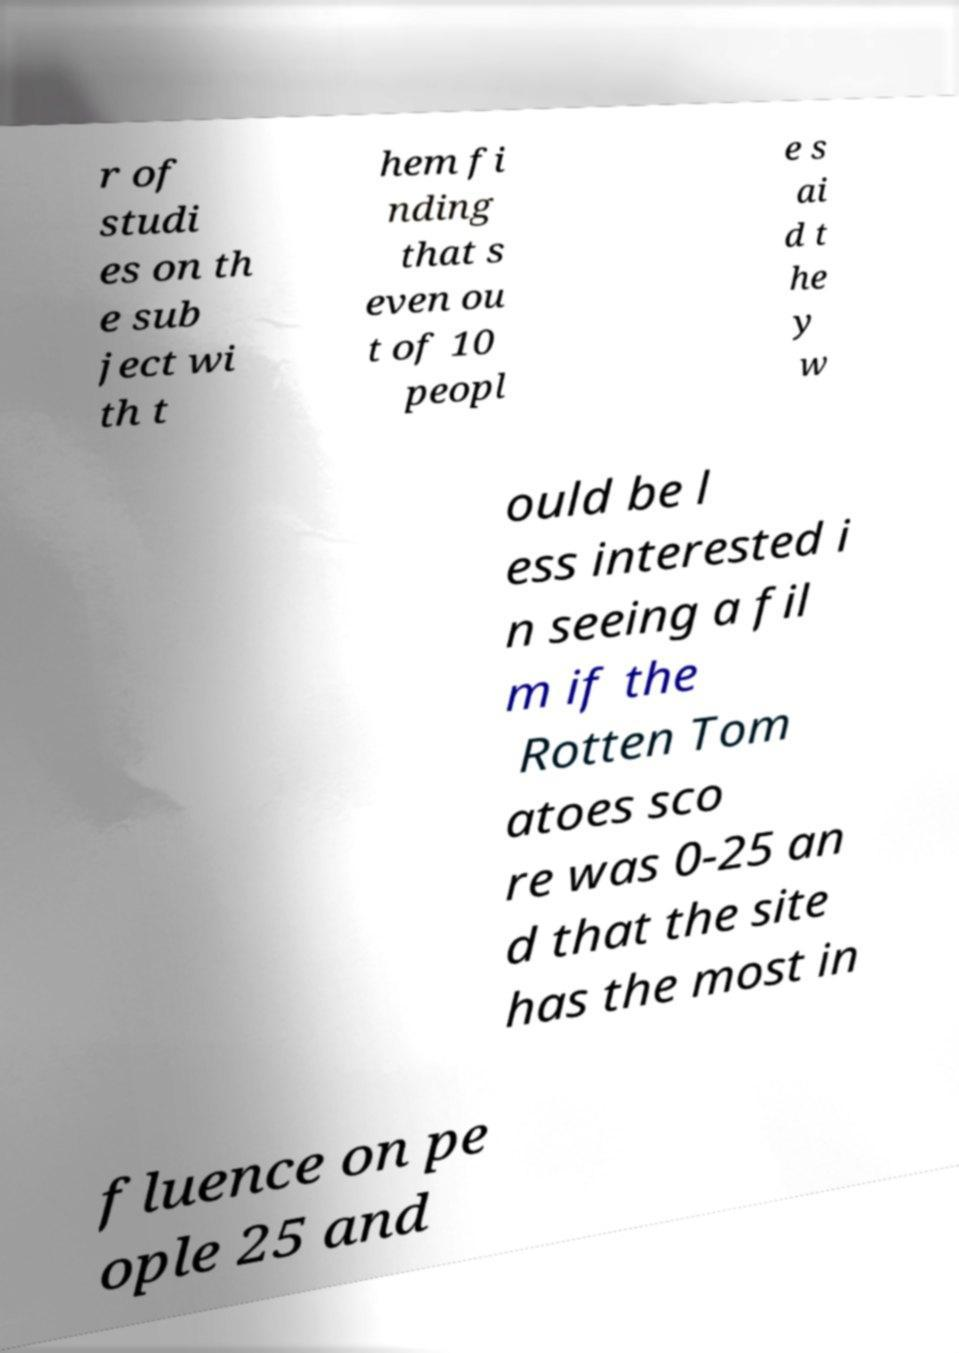For documentation purposes, I need the text within this image transcribed. Could you provide that? r of studi es on th e sub ject wi th t hem fi nding that s even ou t of 10 peopl e s ai d t he y w ould be l ess interested i n seeing a fil m if the Rotten Tom atoes sco re was 0-25 an d that the site has the most in fluence on pe ople 25 and 